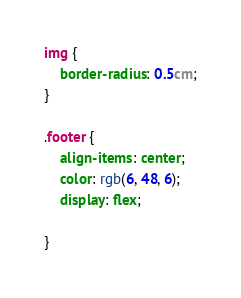<code> <loc_0><loc_0><loc_500><loc_500><_CSS_>img {
    border-radius: 0.5cm;
}

.footer {
    align-items: center;
    color: rgb(6, 48, 6);
    display: flex;

}</code> 